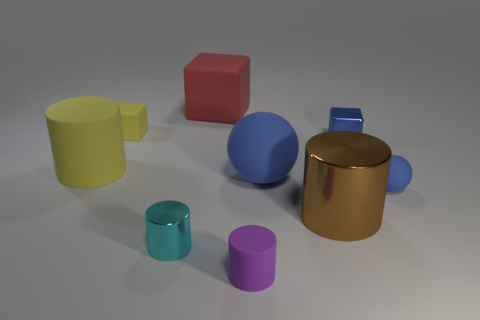Add 1 tiny cyan metal things. How many objects exist? 10 Subtract all spheres. How many objects are left? 7 Add 5 brown metallic cylinders. How many brown metallic cylinders are left? 6 Add 4 matte cylinders. How many matte cylinders exist? 6 Subtract 0 green blocks. How many objects are left? 9 Subtract all large purple metal things. Subtract all tiny blue objects. How many objects are left? 7 